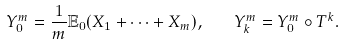<formula> <loc_0><loc_0><loc_500><loc_500>Y _ { 0 } ^ { m } = \frac { 1 } { m } \mathbb { E } _ { 0 } ( X _ { 1 } + \cdots + X _ { m } ) , \quad Y _ { k } ^ { m } = Y _ { 0 } ^ { m } \circ T ^ { k } .</formula> 